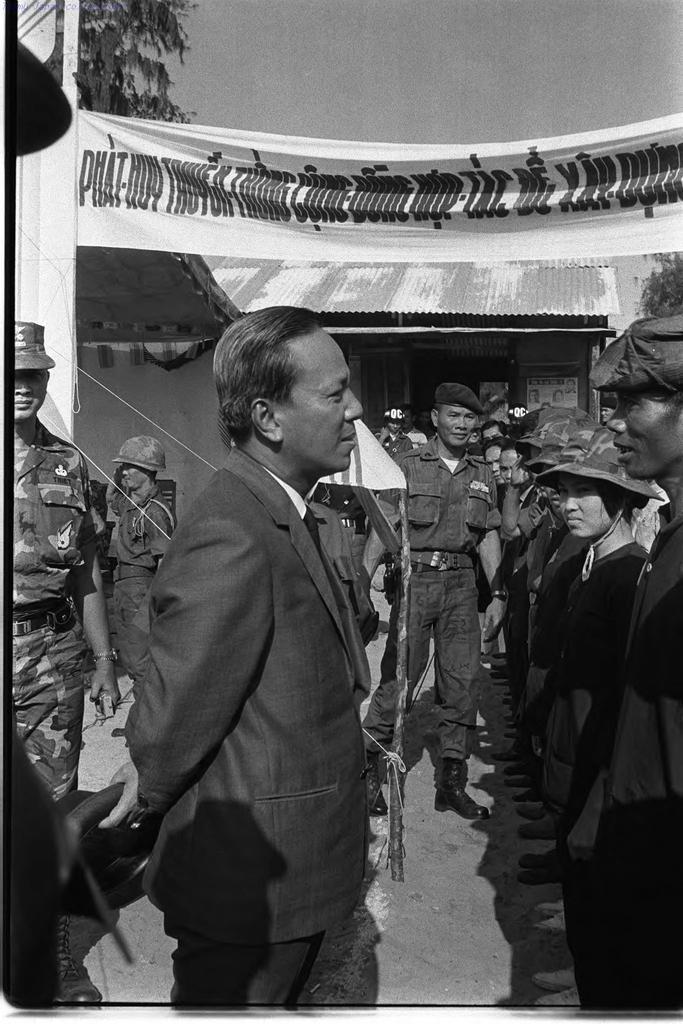Could you give a brief overview of what you see in this image? In this image I can see number of people are standing. I can see most of them are wearing uniforms, caps and over there I can see one of them is wearing a helmet. I can also few trees, a banner and on it I can see something is written. I can also see this image is black and white in colour. 